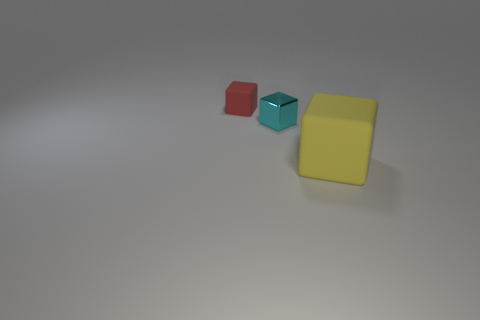There is a matte cube in front of the metal thing; does it have the same size as the matte block that is behind the cyan object?
Provide a succinct answer. No. Are there any other things that are made of the same material as the tiny cyan block?
Your answer should be compact. No. There is a small cyan object that is in front of the small cube on the left side of the small block that is to the right of the tiny rubber cube; what is its material?
Your answer should be compact. Metal. Does the small cyan thing have the same shape as the large matte thing?
Offer a terse response. Yes. What is the material of the large thing that is the same shape as the small red thing?
Offer a very short reply. Rubber. What size is the other thing that is the same material as the large thing?
Give a very brief answer. Small. How many cyan things are either large objects or shiny cubes?
Offer a very short reply. 1. There is a cube that is on the left side of the cyan object; what number of yellow things are in front of it?
Your answer should be very brief. 1. Are there more small red objects on the right side of the big yellow thing than small matte objects that are on the left side of the red object?
Provide a short and direct response. No. What is the red thing made of?
Your response must be concise. Rubber. 